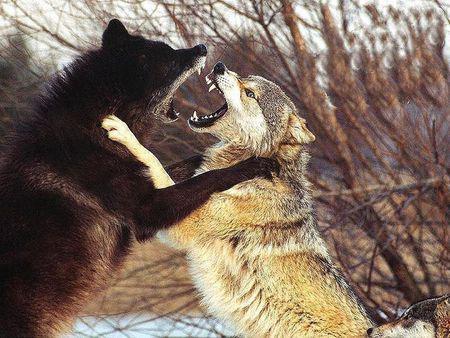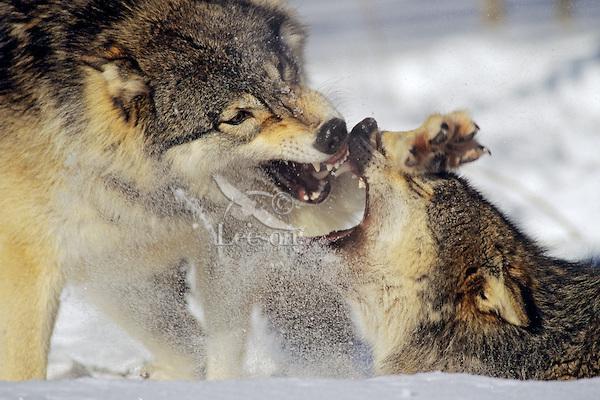The first image is the image on the left, the second image is the image on the right. Examine the images to the left and right. Is the description "The left image contains exactly two wolves." accurate? Answer yes or no. Yes. The first image is the image on the left, the second image is the image on the right. Assess this claim about the two images: "Each image contains exactly two wolves who are close together, and in at least one image, the two wolves are facing off, with snarling mouths.". Correct or not? Answer yes or no. Yes. 